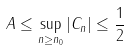<formula> <loc_0><loc_0><loc_500><loc_500>\| \ A \| \leq \sup _ { n \geq n _ { 0 } } | C _ { n } | \leq \frac { 1 } { 2 }</formula> 